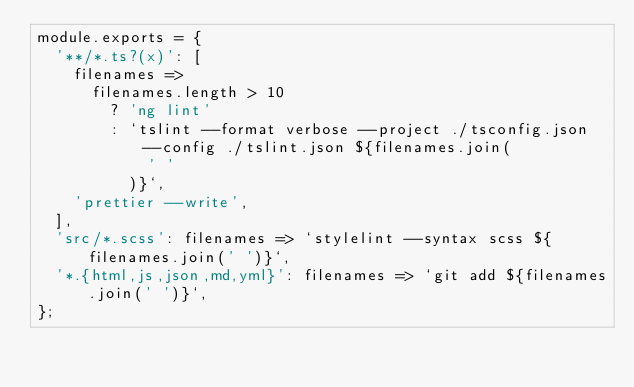<code> <loc_0><loc_0><loc_500><loc_500><_JavaScript_>module.exports = {
  '**/*.ts?(x)': [
    filenames =>
      filenames.length > 10
        ? 'ng lint'
        : `tslint --format verbose --project ./tsconfig.json --config ./tslint.json ${filenames.join(
            ' '
          )}`,
    'prettier --write',
  ],
  'src/*.scss': filenames => `stylelint --syntax scss ${filenames.join(' ')}`,
  '*.{html,js,json,md,yml}': filenames => `git add ${filenames.join(' ')}`,
};
</code> 